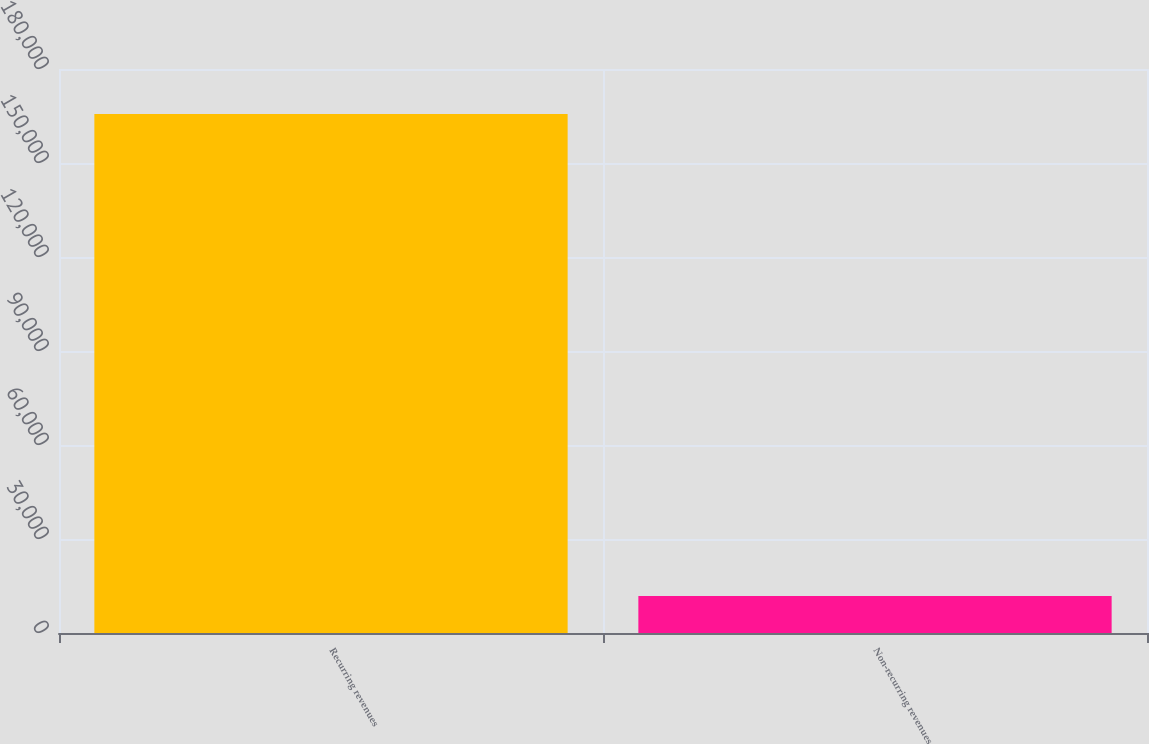Convert chart to OTSL. <chart><loc_0><loc_0><loc_500><loc_500><bar_chart><fcel>Recurring revenues<fcel>Non-recurring revenues<nl><fcel>165669<fcel>11833<nl></chart> 